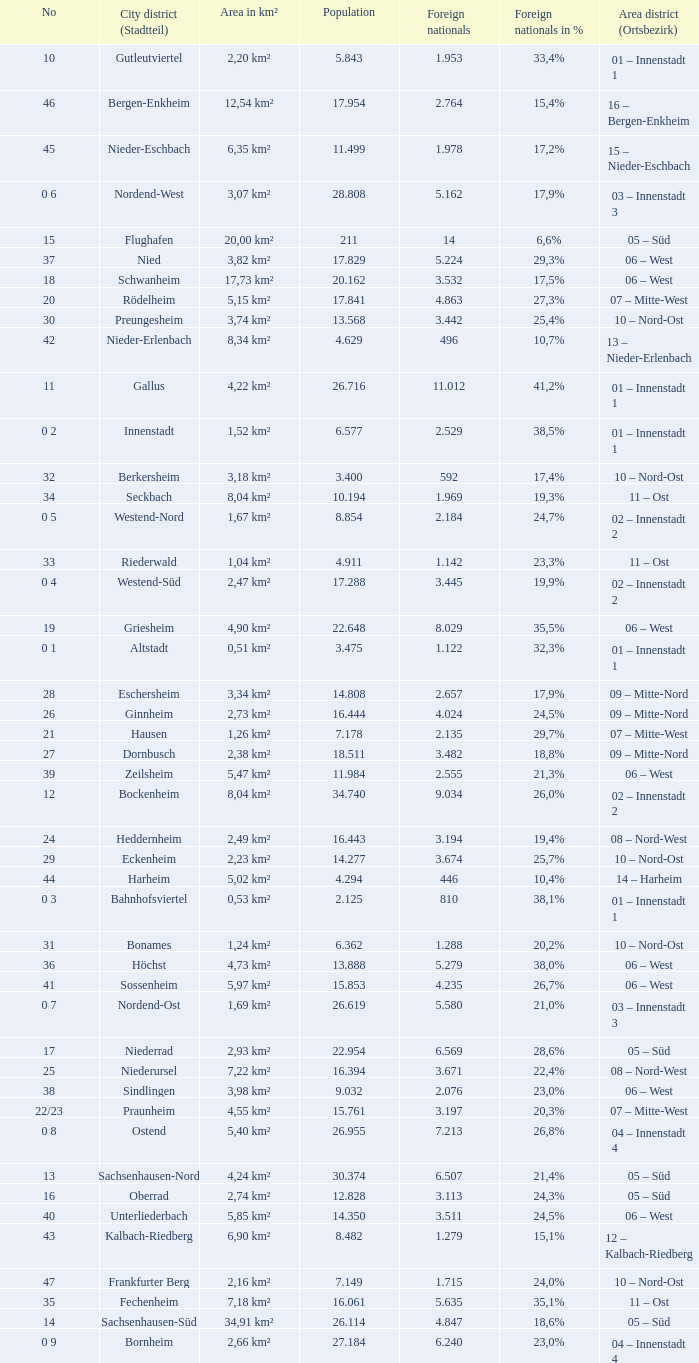What is the number of the city district of stadtteil where foreigners are 5.162? 1.0. Would you be able to parse every entry in this table? {'header': ['No', 'City district (Stadtteil)', 'Area in km²', 'Population', 'Foreign nationals', 'Foreign nationals in %', 'Area district (Ortsbezirk)'], 'rows': [['10', 'Gutleutviertel', '2,20 km²', '5.843', '1.953', '33,4%', '01 – Innenstadt 1'], ['46', 'Bergen-Enkheim', '12,54 km²', '17.954', '2.764', '15,4%', '16 – Bergen-Enkheim'], ['45', 'Nieder-Eschbach', '6,35 km²', '11.499', '1.978', '17,2%', '15 – Nieder-Eschbach'], ['0 6', 'Nordend-West', '3,07 km²', '28.808', '5.162', '17,9%', '03 – Innenstadt 3'], ['15', 'Flughafen', '20,00 km²', '211', '14', '6,6%', '05 – Süd'], ['37', 'Nied', '3,82 km²', '17.829', '5.224', '29,3%', '06 – West'], ['18', 'Schwanheim', '17,73 km²', '20.162', '3.532', '17,5%', '06 – West'], ['20', 'Rödelheim', '5,15 km²', '17.841', '4.863', '27,3%', '07 – Mitte-West'], ['30', 'Preungesheim', '3,74 km²', '13.568', '3.442', '25,4%', '10 – Nord-Ost'], ['42', 'Nieder-Erlenbach', '8,34 km²', '4.629', '496', '10,7%', '13 – Nieder-Erlenbach'], ['11', 'Gallus', '4,22 km²', '26.716', '11.012', '41,2%', '01 – Innenstadt 1'], ['0 2', 'Innenstadt', '1,52 km²', '6.577', '2.529', '38,5%', '01 – Innenstadt 1'], ['32', 'Berkersheim', '3,18 km²', '3.400', '592', '17,4%', '10 – Nord-Ost'], ['34', 'Seckbach', '8,04 km²', '10.194', '1.969', '19,3%', '11 – Ost'], ['0 5', 'Westend-Nord', '1,67 km²', '8.854', '2.184', '24,7%', '02 – Innenstadt 2'], ['33', 'Riederwald', '1,04 km²', '4.911', '1.142', '23,3%', '11 – Ost'], ['0 4', 'Westend-Süd', '2,47 km²', '17.288', '3.445', '19,9%', '02 – Innenstadt 2'], ['19', 'Griesheim', '4,90 km²', '22.648', '8.029', '35,5%', '06 – West'], ['0 1', 'Altstadt', '0,51 km²', '3.475', '1.122', '32,3%', '01 – Innenstadt 1'], ['28', 'Eschersheim', '3,34 km²', '14.808', '2.657', '17,9%', '09 – Mitte-Nord'], ['26', 'Ginnheim', '2,73 km²', '16.444', '4.024', '24,5%', '09 – Mitte-Nord'], ['21', 'Hausen', '1,26 km²', '7.178', '2.135', '29,7%', '07 – Mitte-West'], ['27', 'Dornbusch', '2,38 km²', '18.511', '3.482', '18,8%', '09 – Mitte-Nord'], ['39', 'Zeilsheim', '5,47 km²', '11.984', '2.555', '21,3%', '06 – West'], ['12', 'Bockenheim', '8,04 km²', '34.740', '9.034', '26,0%', '02 – Innenstadt 2'], ['24', 'Heddernheim', '2,49 km²', '16.443', '3.194', '19,4%', '08 – Nord-West'], ['29', 'Eckenheim', '2,23 km²', '14.277', '3.674', '25,7%', '10 – Nord-Ost'], ['44', 'Harheim', '5,02 km²', '4.294', '446', '10,4%', '14 – Harheim'], ['0 3', 'Bahnhofsviertel', '0,53 km²', '2.125', '810', '38,1%', '01 – Innenstadt 1'], ['31', 'Bonames', '1,24 km²', '6.362', '1.288', '20,2%', '10 – Nord-Ost'], ['36', 'Höchst', '4,73 km²', '13.888', '5.279', '38,0%', '06 – West'], ['41', 'Sossenheim', '5,97 km²', '15.853', '4.235', '26,7%', '06 – West'], ['0 7', 'Nordend-Ost', '1,69 km²', '26.619', '5.580', '21,0%', '03 – Innenstadt 3'], ['17', 'Niederrad', '2,93 km²', '22.954', '6.569', '28,6%', '05 – Süd'], ['25', 'Niederursel', '7,22 km²', '16.394', '3.671', '22,4%', '08 – Nord-West'], ['38', 'Sindlingen', '3,98 km²', '9.032', '2.076', '23,0%', '06 – West'], ['22/23', 'Praunheim', '4,55 km²', '15.761', '3.197', '20,3%', '07 – Mitte-West'], ['0 8', 'Ostend', '5,40 km²', '26.955', '7.213', '26,8%', '04 – Innenstadt 4'], ['13', 'Sachsenhausen-Nord', '4,24 km²', '30.374', '6.507', '21,4%', '05 – Süd'], ['16', 'Oberrad', '2,74 km²', '12.828', '3.113', '24,3%', '05 – Süd'], ['40', 'Unterliederbach', '5,85 km²', '14.350', '3.511', '24,5%', '06 – West'], ['43', 'Kalbach-Riedberg', '6,90 km²', '8.482', '1.279', '15,1%', '12 – Kalbach-Riedberg'], ['47', 'Frankfurter Berg', '2,16 km²', '7.149', '1.715', '24,0%', '10 – Nord-Ost'], ['35', 'Fechenheim', '7,18 km²', '16.061', '5.635', '35,1%', '11 – Ost'], ['14', 'Sachsenhausen-Süd', '34,91 km²', '26.114', '4.847', '18,6%', '05 – Süd'], ['0 9', 'Bornheim', '2,66 km²', '27.184', '6.240', '23,0%', '04 – Innenstadt 4']]} 